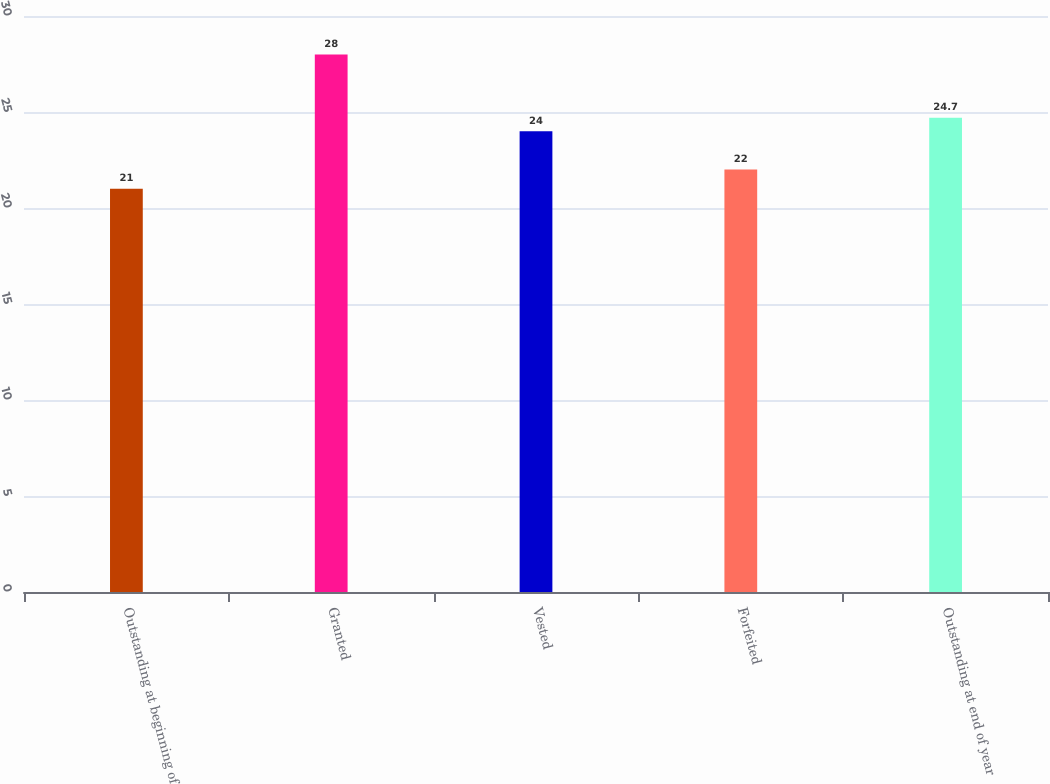<chart> <loc_0><loc_0><loc_500><loc_500><bar_chart><fcel>Outstanding at beginning of<fcel>Granted<fcel>Vested<fcel>Forfeited<fcel>Outstanding at end of year<nl><fcel>21<fcel>28<fcel>24<fcel>22<fcel>24.7<nl></chart> 